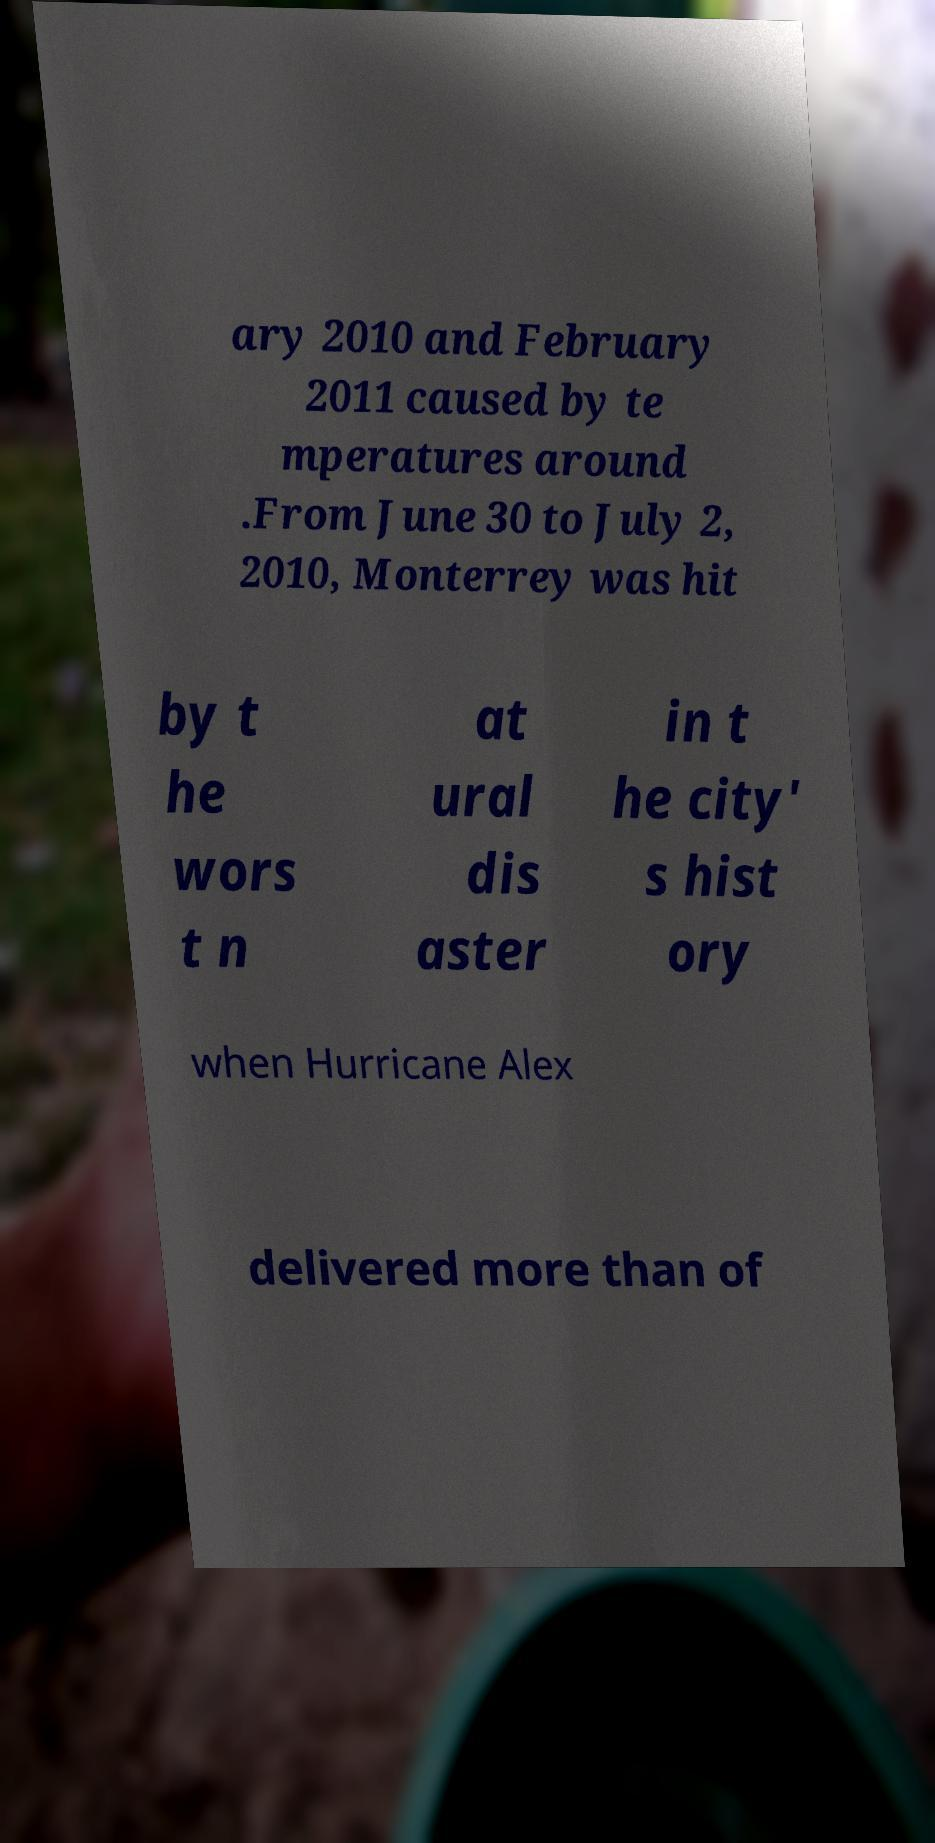Could you assist in decoding the text presented in this image and type it out clearly? ary 2010 and February 2011 caused by te mperatures around .From June 30 to July 2, 2010, Monterrey was hit by t he wors t n at ural dis aster in t he city' s hist ory when Hurricane Alex delivered more than of 